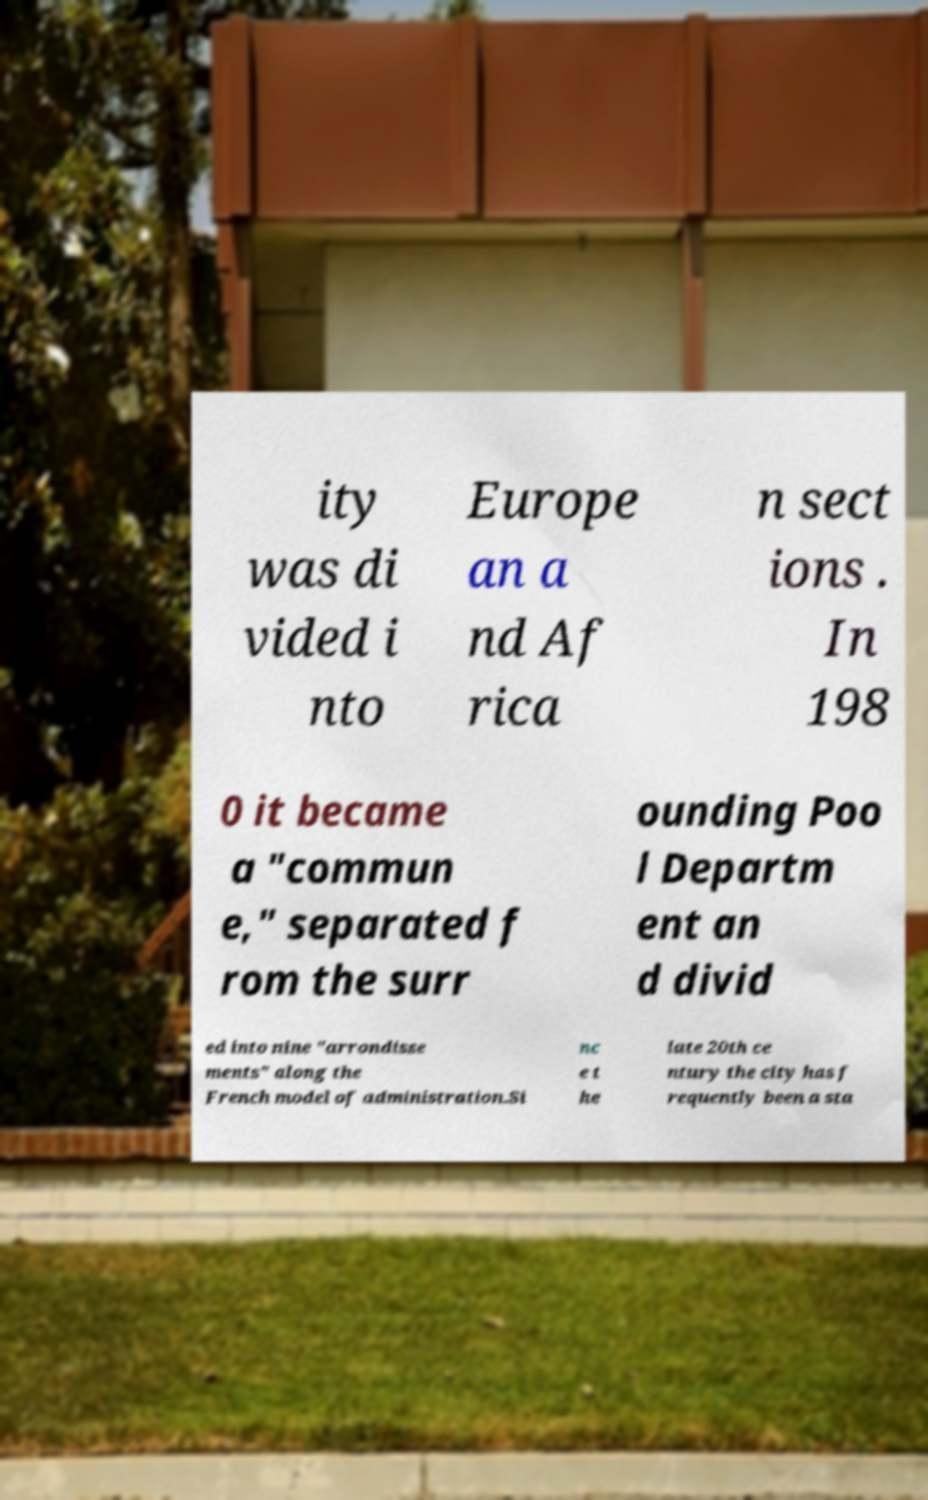Please read and relay the text visible in this image. What does it say? ity was di vided i nto Europe an a nd Af rica n sect ions . In 198 0 it became a "commun e," separated f rom the surr ounding Poo l Departm ent an d divid ed into nine "arrondisse ments" along the French model of administration.Si nc e t he late 20th ce ntury the city has f requently been a sta 